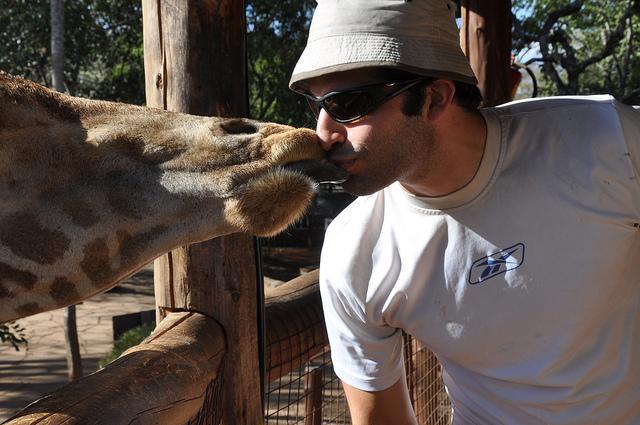How many people can you see?
Give a very brief answer. 1. How many yellow bikes are there?
Give a very brief answer. 0. 